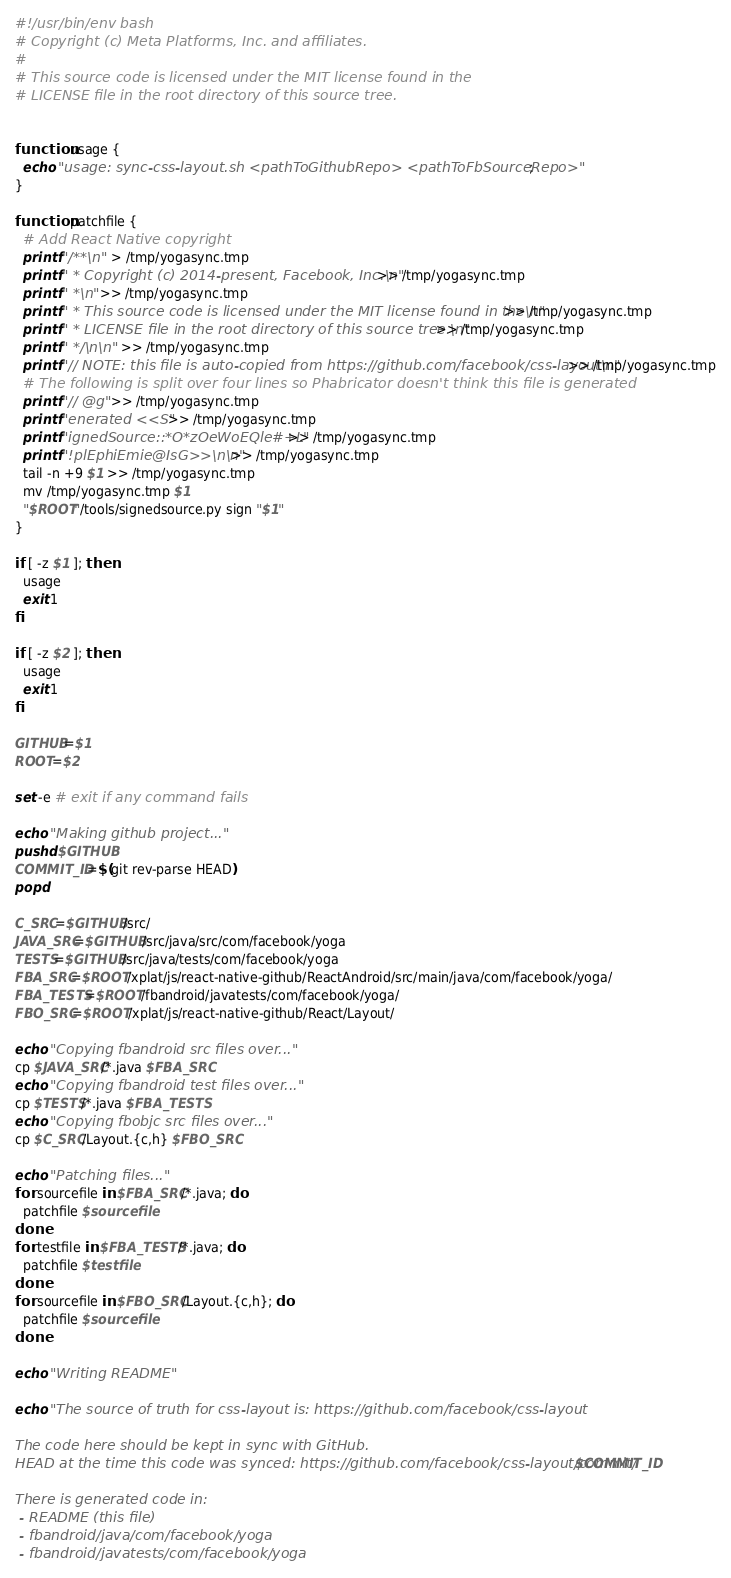Convert code to text. <code><loc_0><loc_0><loc_500><loc_500><_Bash_>#!/usr/bin/env bash
# Copyright (c) Meta Platforms, Inc. and affiliates.
#
# This source code is licensed under the MIT license found in the
# LICENSE file in the root directory of this source tree.


function usage {
  echo "usage: sync-css-layout.sh <pathToGithubRepo> <pathToFbSourceRepo>";
}

function patchfile {
  # Add React Native copyright
  printf "/**\n"  > /tmp/yogasync.tmp
  printf " * Copyright (c) 2014-present, Facebook, Inc.\n"  >> /tmp/yogasync.tmp
  printf " *\n" >> /tmp/yogasync.tmp
  printf " * This source code is licensed under the MIT license found in the\n"  >> /tmp/yogasync.tmp
  printf " * LICENSE file in the root directory of this source tree.\n"  >> /tmp/yogasync.tmp
  printf " */\n\n"  >> /tmp/yogasync.tmp
  printf "// NOTE: this file is auto-copied from https://github.com/facebook/css-layout\n" >> /tmp/yogasync.tmp
  # The following is split over four lines so Phabricator doesn't think this file is generated
  printf "// @g" >> /tmp/yogasync.tmp
  printf "enerated <<S" >> /tmp/yogasync.tmp
  printf "ignedSource::*O*zOeWoEQle#+L" >> /tmp/yogasync.tmp
  printf "!plEphiEmie@IsG>>\n\n" >> /tmp/yogasync.tmp
  tail -n +9 $1 >> /tmp/yogasync.tmp
  mv /tmp/yogasync.tmp $1
  "$ROOT"/tools/signedsource.py sign "$1"
}

if [ -z $1 ]; then
  usage
  exit 1
fi

if [ -z $2 ]; then
  usage
  exit 1
fi

GITHUB=$1
ROOT=$2

set -e # exit if any command fails

echo "Making github project..."
pushd $GITHUB
COMMIT_ID=$(git rev-parse HEAD)
popd

C_SRC=$GITHUB/src/
JAVA_SRC=$GITHUB/src/java/src/com/facebook/yoga
TESTS=$GITHUB/src/java/tests/com/facebook/yoga
FBA_SRC=$ROOT/xplat/js/react-native-github/ReactAndroid/src/main/java/com/facebook/yoga/
FBA_TESTS=$ROOT/fbandroid/javatests/com/facebook/yoga/
FBO_SRC=$ROOT/xplat/js/react-native-github/React/Layout/

echo "Copying fbandroid src files over..."
cp $JAVA_SRC/*.java $FBA_SRC
echo "Copying fbandroid test files over..."
cp $TESTS/*.java $FBA_TESTS
echo "Copying fbobjc src files over..."
cp $C_SRC/Layout.{c,h} $FBO_SRC

echo "Patching files..."
for sourcefile in $FBA_SRC/*.java; do
  patchfile $sourcefile
done
for testfile in $FBA_TESTS/*.java; do
  patchfile $testfile
done
for sourcefile in $FBO_SRC/Layout.{c,h}; do
  patchfile $sourcefile
done

echo "Writing README"

echo "The source of truth for css-layout is: https://github.com/facebook/css-layout

The code here should be kept in sync with GitHub.
HEAD at the time this code was synced: https://github.com/facebook/css-layout/commit/$COMMIT_ID

There is generated code in:
 - README (this file)
 - fbandroid/java/com/facebook/yoga
 - fbandroid/javatests/com/facebook/yoga</code> 